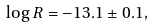Convert formula to latex. <formula><loc_0><loc_0><loc_500><loc_500>\log R = - 1 3 . 1 \pm 0 . 1 ,</formula> 